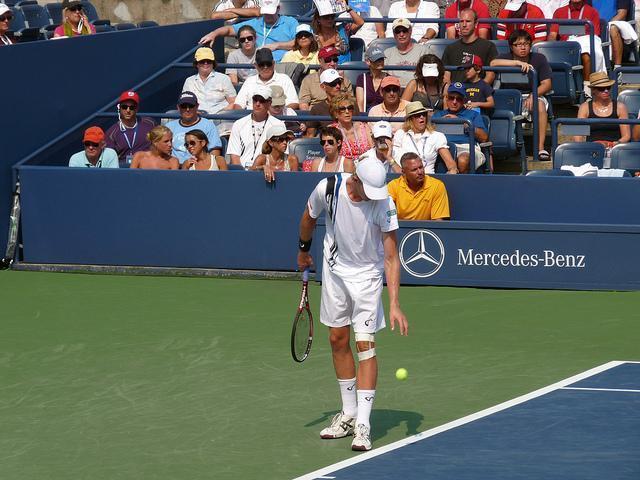How many people can be seen?
Give a very brief answer. 7. How many sinks are there?
Give a very brief answer. 0. 